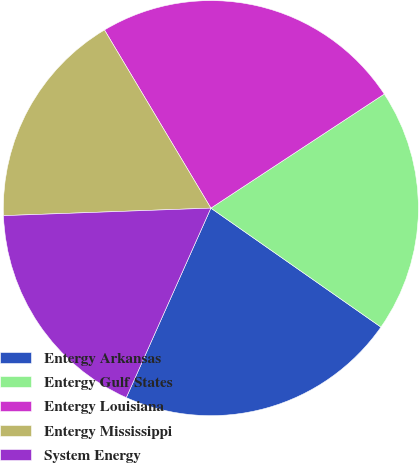Convert chart. <chart><loc_0><loc_0><loc_500><loc_500><pie_chart><fcel>Entergy Arkansas<fcel>Entergy Gulf States<fcel>Entergy Louisiana<fcel>Entergy Mississippi<fcel>System Energy<nl><fcel>21.97%<fcel>18.98%<fcel>24.31%<fcel>17.01%<fcel>17.74%<nl></chart> 